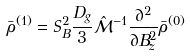<formula> <loc_0><loc_0><loc_500><loc_500>\bar { \rho } ^ { ( 1 ) } = S _ { B } ^ { 2 } \frac { D _ { g } } { 3 } \hat { \mathcal { M } } ^ { - 1 } \frac { \partial ^ { 2 } } { \partial B _ { z } ^ { 2 } } \bar { \rho } ^ { ( 0 ) }</formula> 